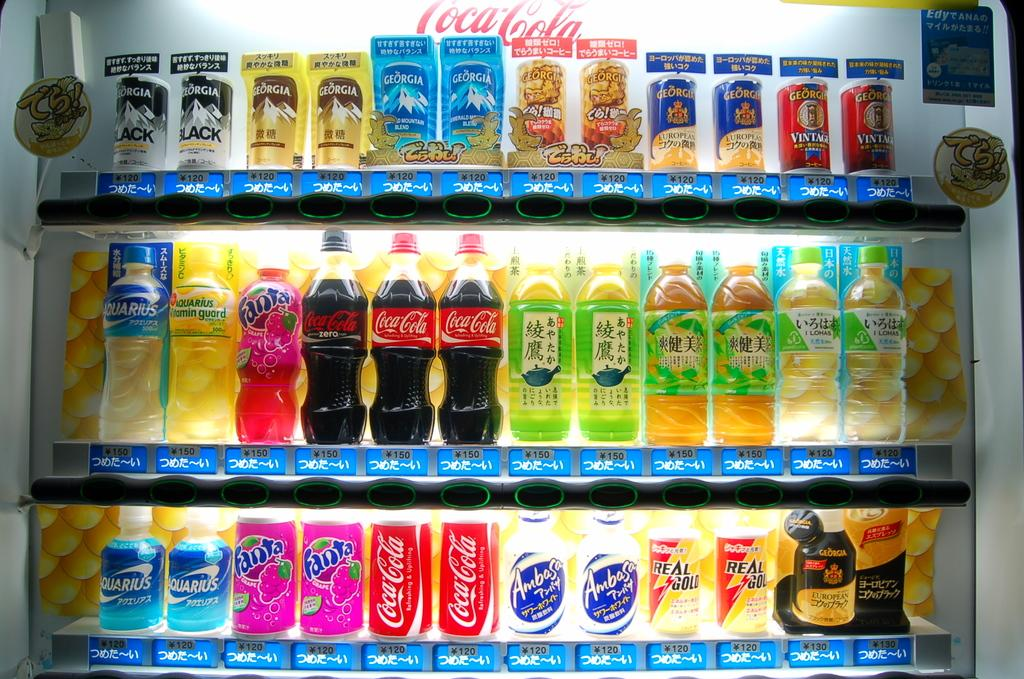<image>
Give a short and clear explanation of the subsequent image. a Coca Cola vending machine with drinks like Fanta and Aquarius for sale 